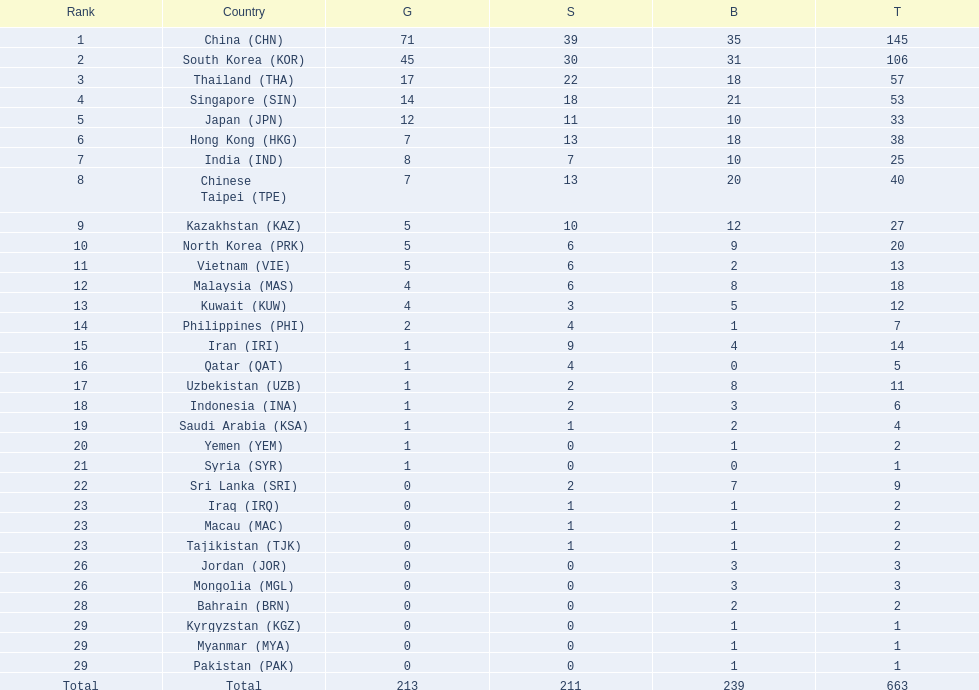What is the total number of medals that india won in the asian youth games? 25. 